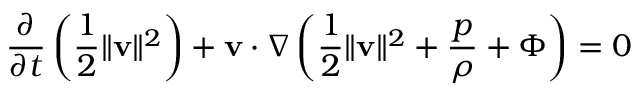Convert formula to latex. <formula><loc_0><loc_0><loc_500><loc_500>{ \frac { \partial } { \partial t } } \left ( { \frac { 1 } { 2 } } \| { v } \| ^ { 2 } \right ) + { v } \cdot \nabla \left ( { \frac { 1 } { 2 } } \| { v } \| ^ { 2 } + { \frac { p } { \rho } } + \Phi \right ) = 0</formula> 